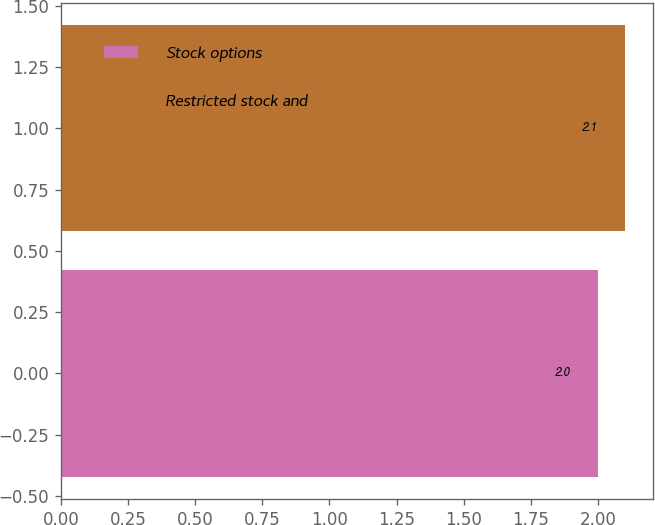<chart> <loc_0><loc_0><loc_500><loc_500><bar_chart><fcel>Stock options<fcel>Restricted stock and<nl><fcel>2<fcel>2.1<nl></chart> 